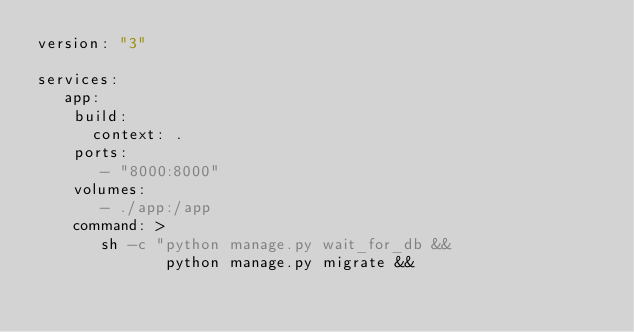Convert code to text. <code><loc_0><loc_0><loc_500><loc_500><_YAML_>version: "3"

services:
   app:
    build:
      context: .
    ports:
       - "8000:8000"
    volumes:
       - ./app:/app
    command: >
       sh -c "python manage.py wait_for_db &&
              python manage.py migrate &&</code> 